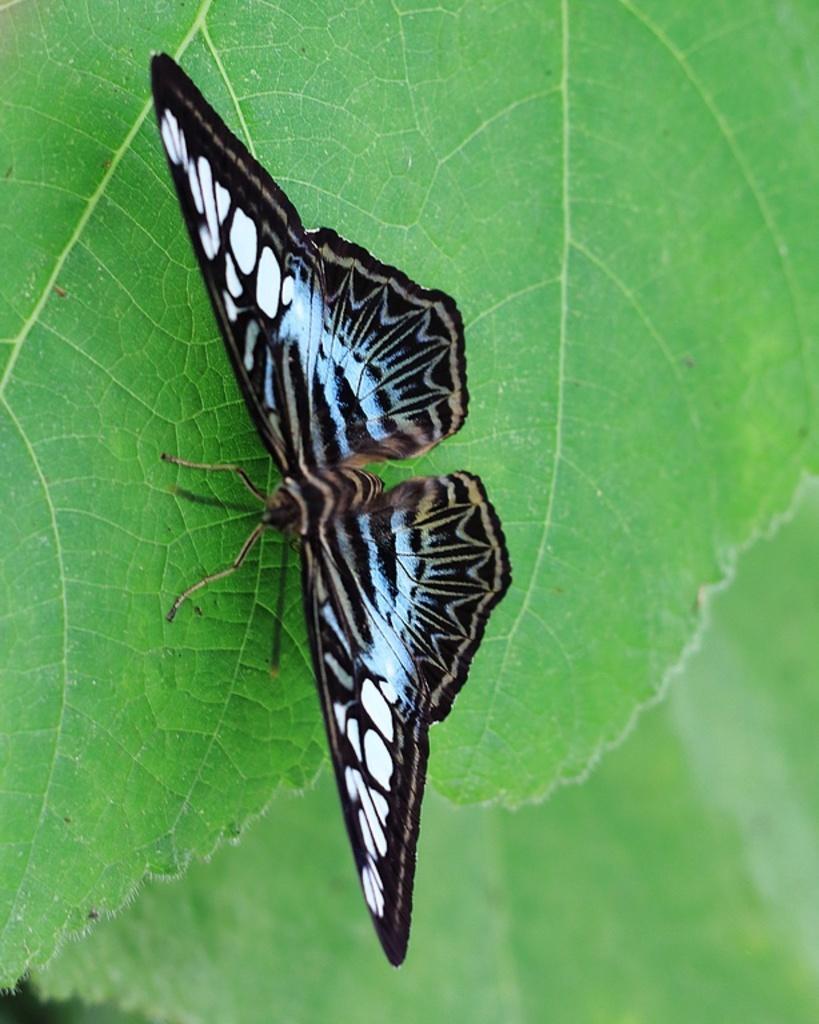Could you give a brief overview of what you see in this image? In this picture there is a butterfly standing on the leaf. At the bottom we can see another leaf. 